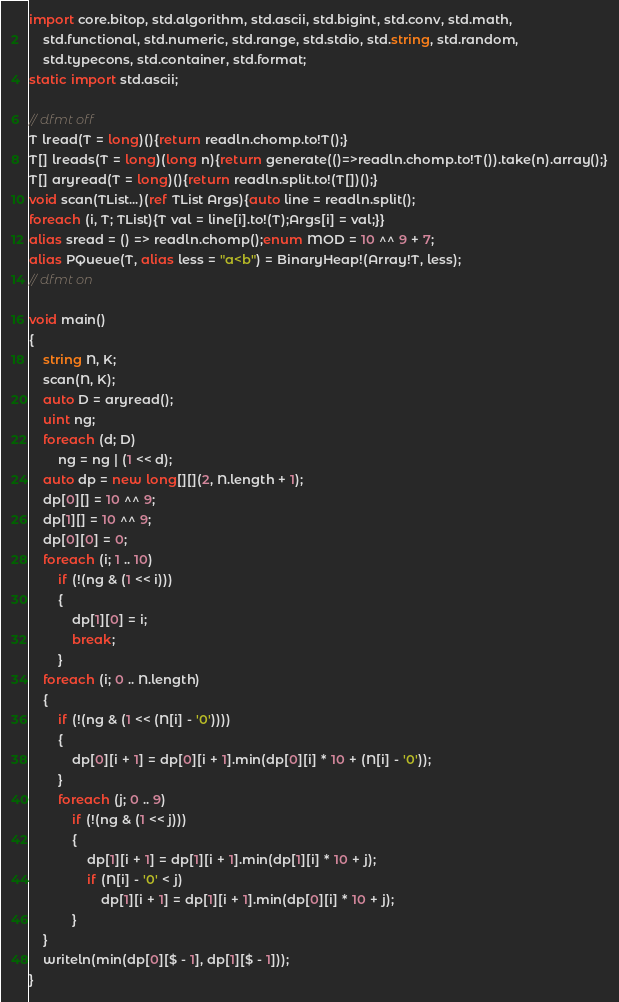Convert code to text. <code><loc_0><loc_0><loc_500><loc_500><_D_>import core.bitop, std.algorithm, std.ascii, std.bigint, std.conv, std.math,
    std.functional, std.numeric, std.range, std.stdio, std.string, std.random,
    std.typecons, std.container, std.format;
static import std.ascii;

// dfmt off
T lread(T = long)(){return readln.chomp.to!T();}
T[] lreads(T = long)(long n){return generate(()=>readln.chomp.to!T()).take(n).array();}
T[] aryread(T = long)(){return readln.split.to!(T[])();}
void scan(TList...)(ref TList Args){auto line = readln.split();
foreach (i, T; TList){T val = line[i].to!(T);Args[i] = val;}}
alias sread = () => readln.chomp();enum MOD = 10 ^^ 9 + 7;
alias PQueue(T, alias less = "a<b") = BinaryHeap!(Array!T, less);
// dfmt on

void main()
{
    string N, K;
    scan(N, K);
    auto D = aryread();
    uint ng;
    foreach (d; D)
        ng = ng | (1 << d);
    auto dp = new long[][](2, N.length + 1);
    dp[0][] = 10 ^^ 9;
    dp[1][] = 10 ^^ 9;
    dp[0][0] = 0;
    foreach (i; 1 .. 10)
        if (!(ng & (1 << i)))
        {
            dp[1][0] = i;
            break;
        }
    foreach (i; 0 .. N.length)
    {
        if (!(ng & (1 << (N[i] - '0'))))
        {
            dp[0][i + 1] = dp[0][i + 1].min(dp[0][i] * 10 + (N[i] - '0'));
        }
        foreach (j; 0 .. 9)
            if (!(ng & (1 << j)))
            {
                dp[1][i + 1] = dp[1][i + 1].min(dp[1][i] * 10 + j);
                if (N[i] - '0' < j)
                    dp[1][i + 1] = dp[1][i + 1].min(dp[0][i] * 10 + j);
            }
    }
    writeln(min(dp[0][$ - 1], dp[1][$ - 1]));
}
</code> 